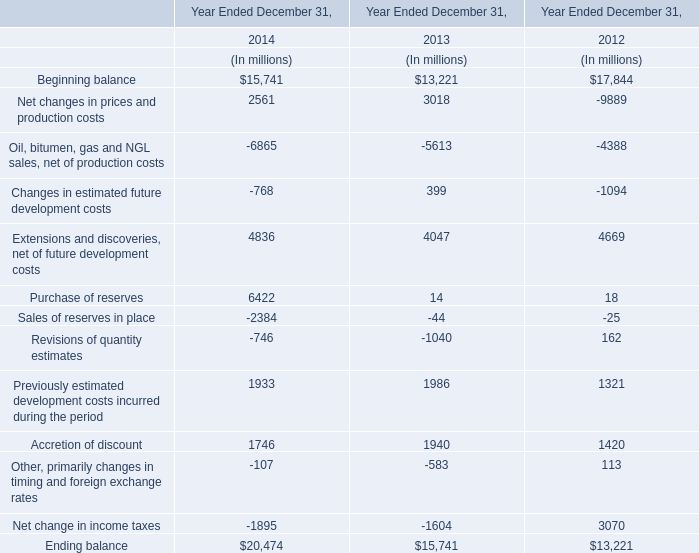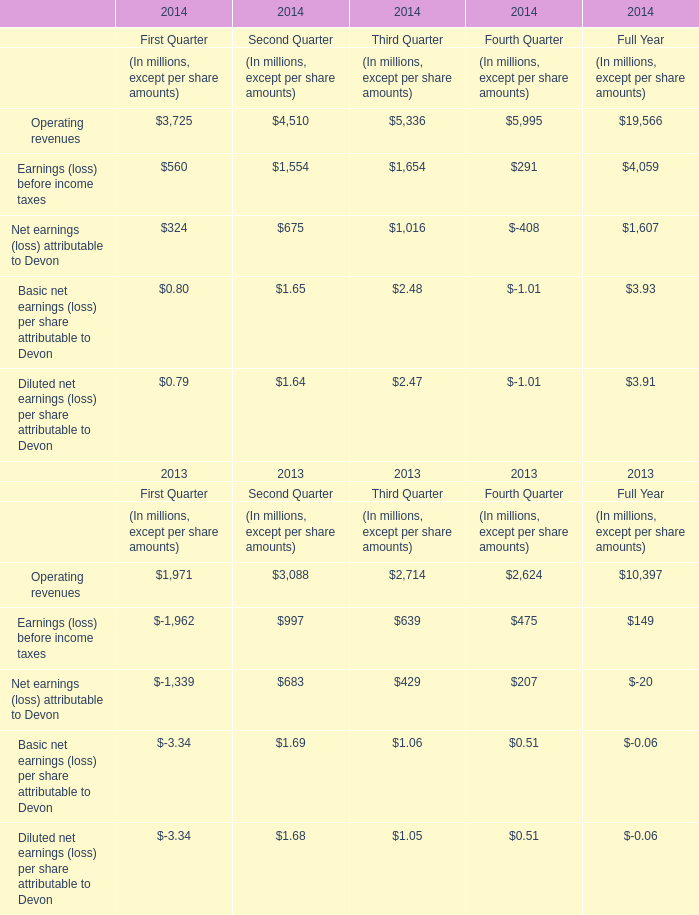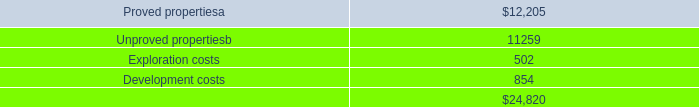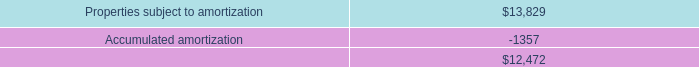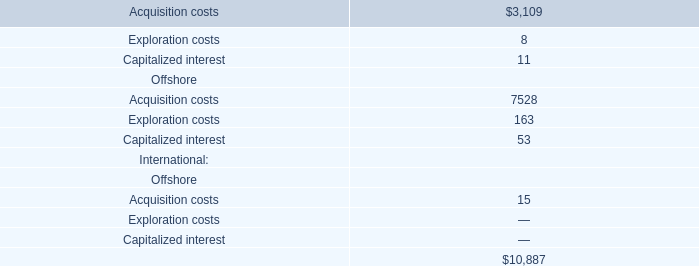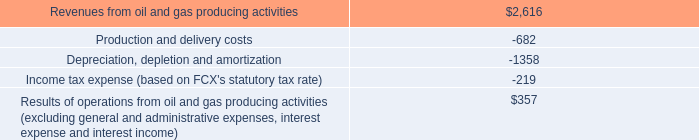What's the total amount of the Purchase of reserves in the year where Beginning balance is greater than 17000? (in dollars in millions) 
Answer: 18. 